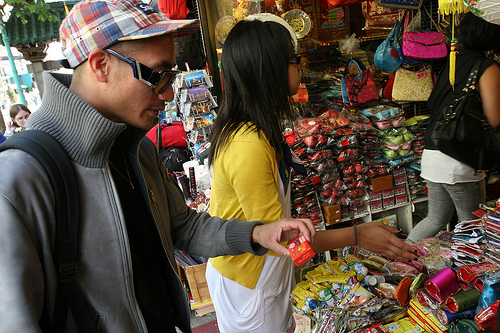<image>
Can you confirm if the person is in front of the man? Yes. The person is positioned in front of the man, appearing closer to the camera viewpoint. 